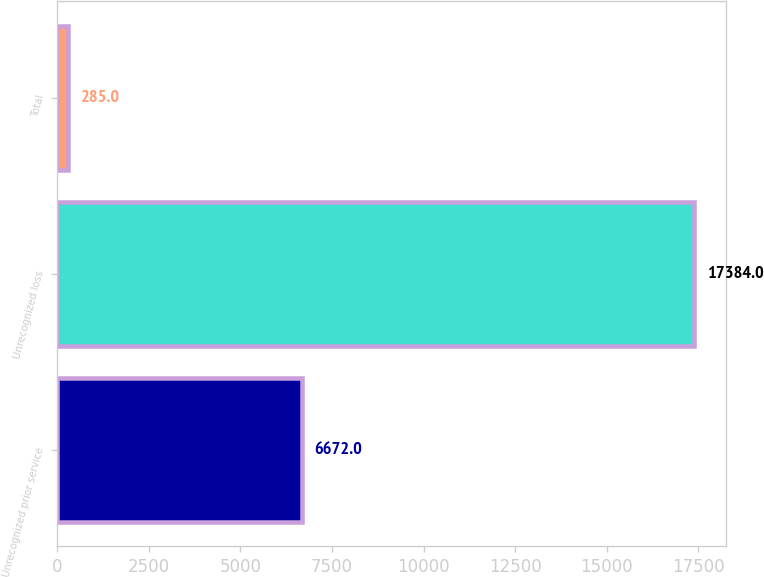Convert chart. <chart><loc_0><loc_0><loc_500><loc_500><bar_chart><fcel>Unrecognized prior service<fcel>Unrecognized loss<fcel>Total<nl><fcel>6672<fcel>17384<fcel>285<nl></chart> 